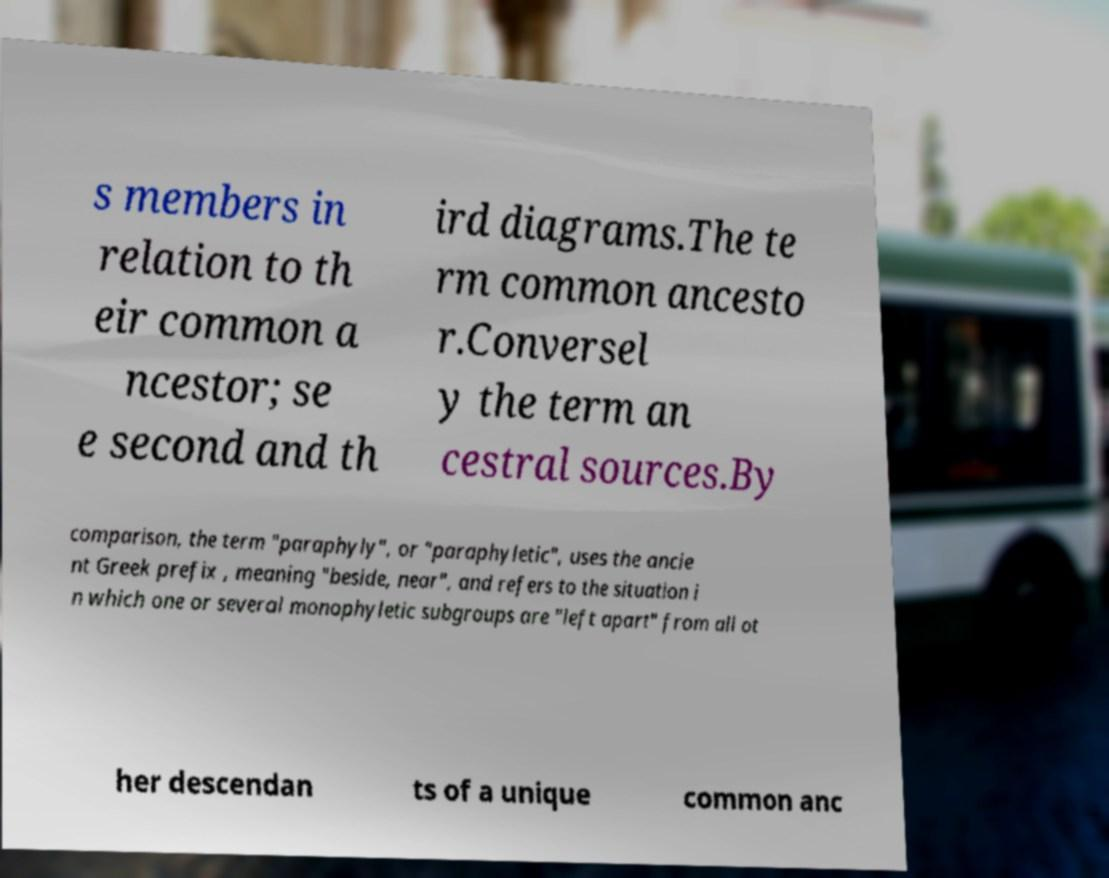Could you extract and type out the text from this image? s members in relation to th eir common a ncestor; se e second and th ird diagrams.The te rm common ancesto r.Conversel y the term an cestral sources.By comparison, the term "paraphyly", or "paraphyletic", uses the ancie nt Greek prefix , meaning "beside, near", and refers to the situation i n which one or several monophyletic subgroups are "left apart" from all ot her descendan ts of a unique common anc 